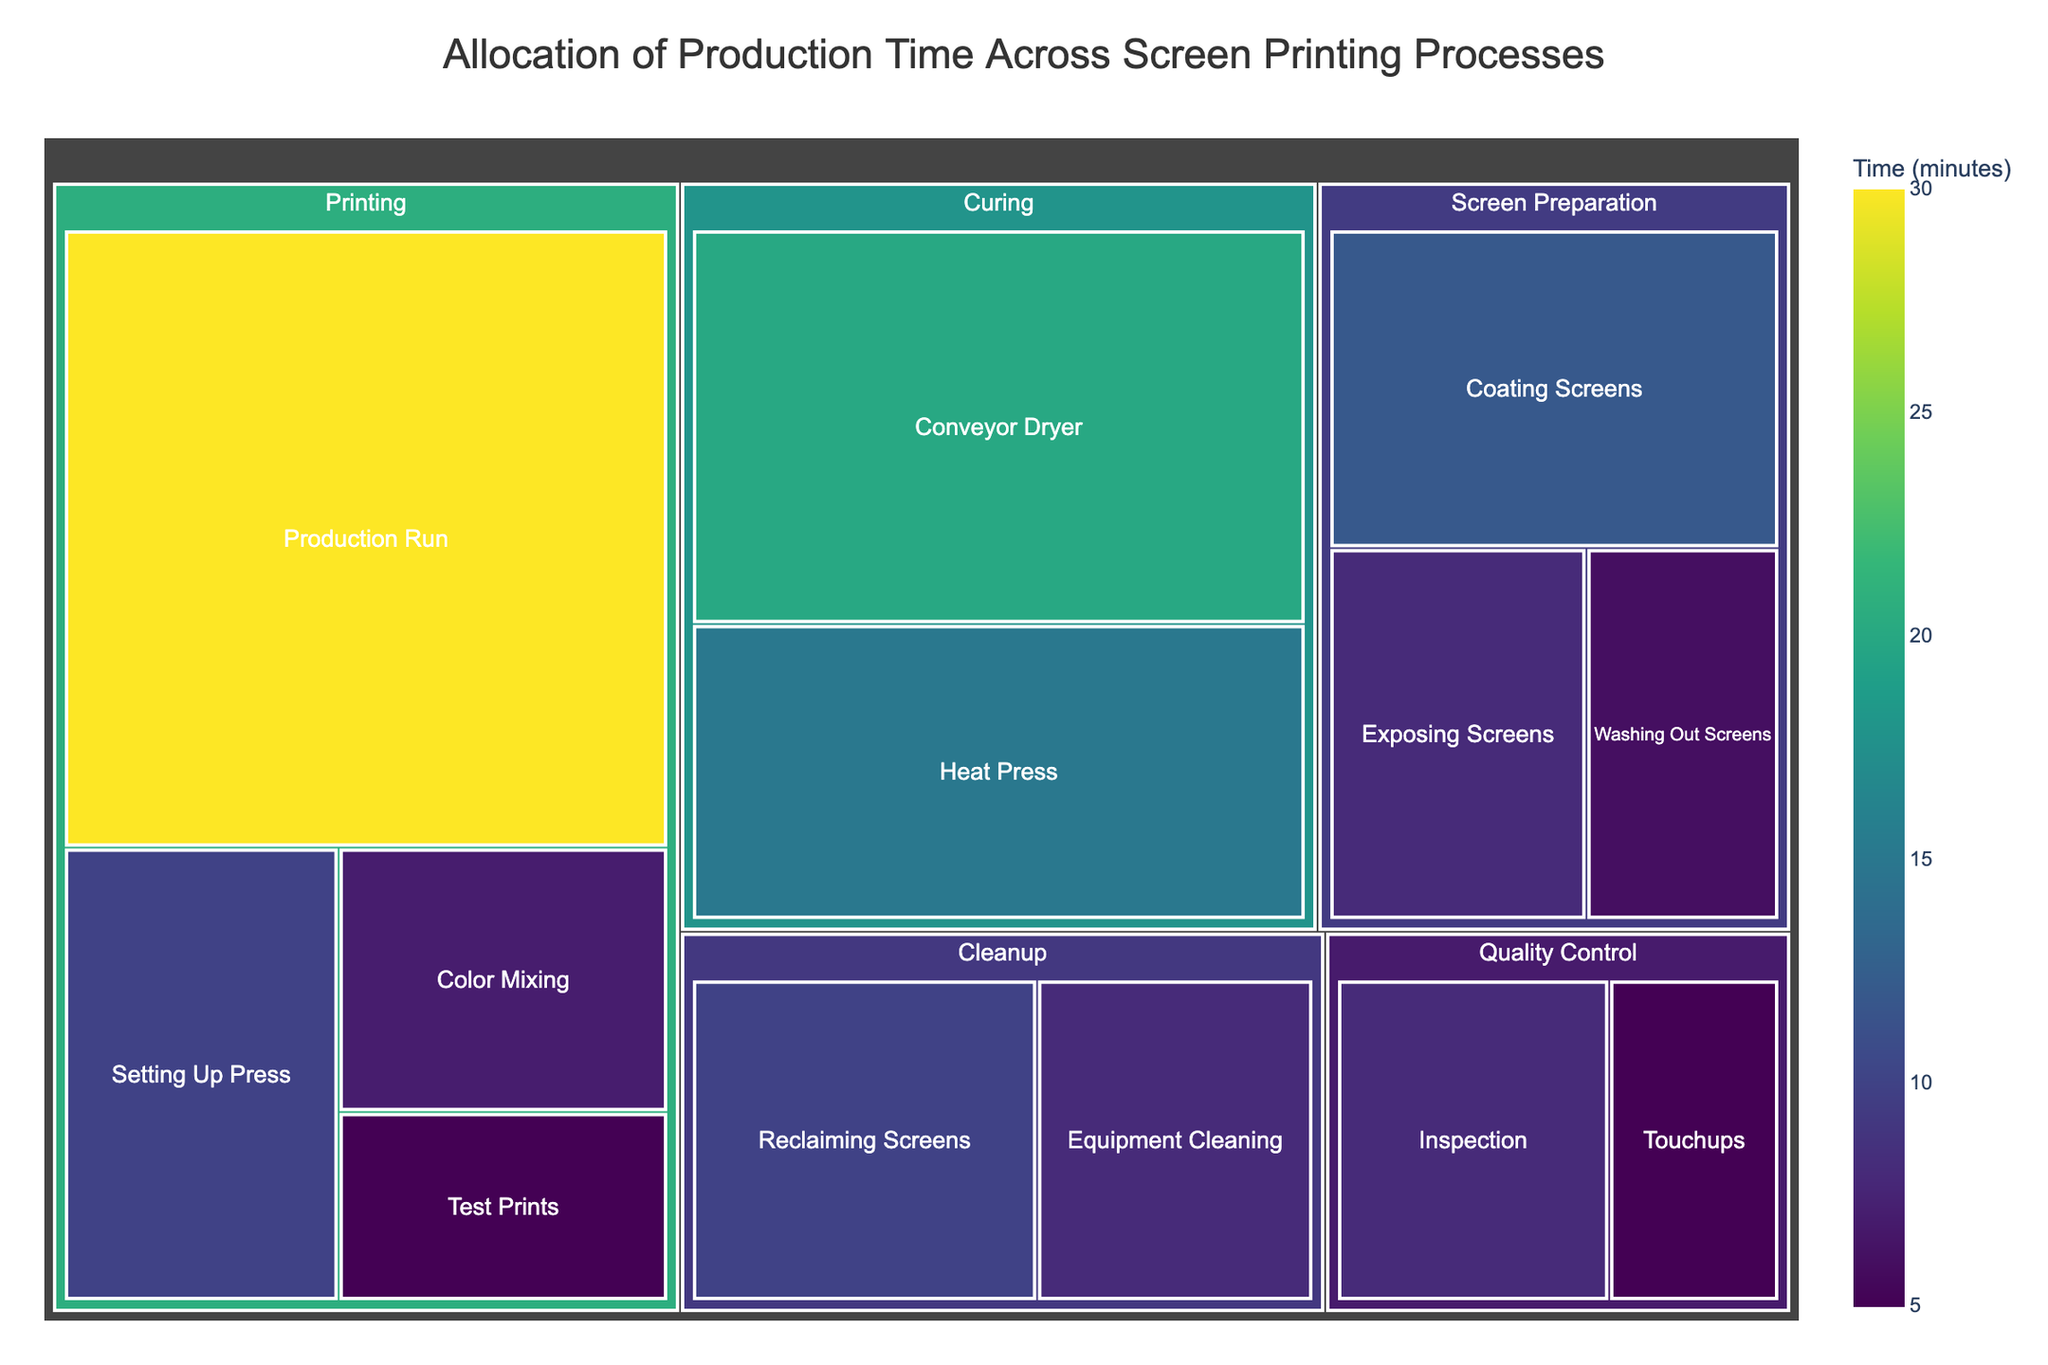what is the total time allocated to the Screen Preparation process? To find the total time for the Screen Preparation process, sum the time values for all sub-processes under it. Adding 12 (Coating Screens) + 8 (Exposing Screens) + 6 (Washing Out Screens) = 26 minutes.
Answer: 26 minutes What process consumes the most production time? By looking at the largest segment in the treemap, it's clear that the Production Run under the Printing process consumes the most time, which is 30 minutes.
Answer: Production Run How much time is spent on Quality Control activities? Sum the time for all sub-processes under Quality Control. Adding 8 (Inspection) + 5 (Touchups) = 13 minutes.
Answer: 13 minutes What is the second most time-consuming process? To determine this, look at the segments sorted by size. The Conveyor Dryer under the Curing process, at 20 minutes, is the next biggest after the Production Run.
Answer: Conveyor Dryer How much time is allocated to the Cleaning process overall? Sum the time for all sub-processes under Cleanup. Adding 10 (Reclaiming Screens) + 8 (Equipment Cleaning) = 18 minutes.
Answer: 18 minutes Which sub-process within Printing takes more time, Color Mixing or Test Prints? Compare the time values for these sub-processes. Color Mixing takes 7 minutes, while Test Prints takes 5 minutes. So, Color Mixing takes more time.
Answer: Color Mixing What is the total time spent on the Curing process? To find this, sum the time values for all sub-processes under Curing. Adding 15 (Heat Press) + 20 (Conveyor Dryer) = 35 minutes.
Answer: 35 minutes What percentage of the total production time does the Production Run constitute? First, sum the total production time, then divide the time of the Production Run by this total and multiply by 100 for the percentage. Total time = 12+8+6+10+7+5+30+15+20+8+5+10+8 = 144 minutes. Production Run time = 30 minutes. So, (30/144) * 100 ≈ 20.83%.
Answer: ~20.83% Which process has the least allocated time, and what's the value? Find the smallest segment in the treemap. The smallest segment is Washing Out Screens under Screen Preparation, with 6 minutes.
Answer: Washing Out Screens, 6 minutes 